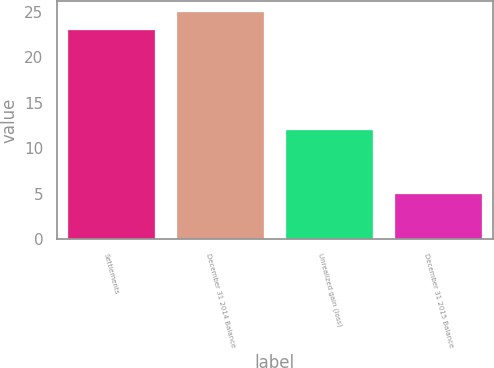Convert chart to OTSL. <chart><loc_0><loc_0><loc_500><loc_500><bar_chart><fcel>Settlements<fcel>December 31 2014 Balance<fcel>Unrealized gain (loss)<fcel>December 31 2015 Balance<nl><fcel>23<fcel>25<fcel>12<fcel>5<nl></chart> 